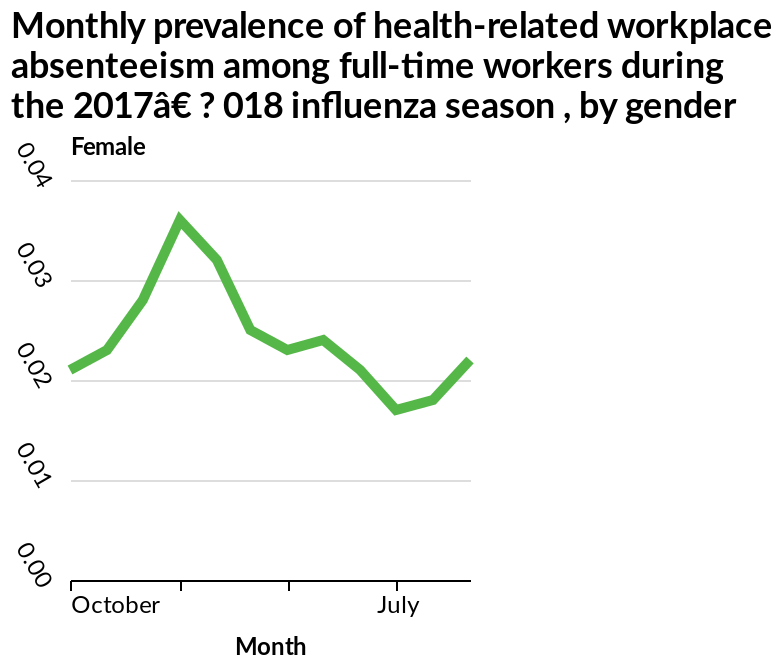<image>
Offer a thorough analysis of the image. Workplace absenteeism for women was higher during the 2017 influenza season. please summary the statistics and relations of the chart The absenteeism of females changes to reach a maximum (0.036) and then decreases to the similar level compared with the beginning (0.02). The beginning is in October. The minimum reaches 0.018 in around July. The maximum is in Feburary. When does the absenteeism of females reach its minimum?  The absenteeism of females reaches its minimum around July. How is the gender defined in the graph?  The gender is defined as female on the y-axis. How does the absenteeism rate of females change after reaching its maximum?  The absenteeism rate of females decreases to a similar level compared with the beginning (0.02) after reaching its maximum. 